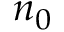Convert formula to latex. <formula><loc_0><loc_0><loc_500><loc_500>n _ { 0 }</formula> 